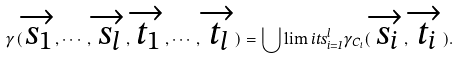<formula> <loc_0><loc_0><loc_500><loc_500>\gamma ( \overrightarrow { s _ { 1 } } , \cdots , \overrightarrow { s _ { l } } , \overrightarrow { t _ { 1 } } , \cdots , \overrightarrow { t _ { l } } ) = \bigcup \lim i t s _ { i = 1 } ^ { l } \gamma _ { C _ { i } } ( \overrightarrow { s _ { i } } , \overrightarrow { t _ { i } } ) .</formula> 